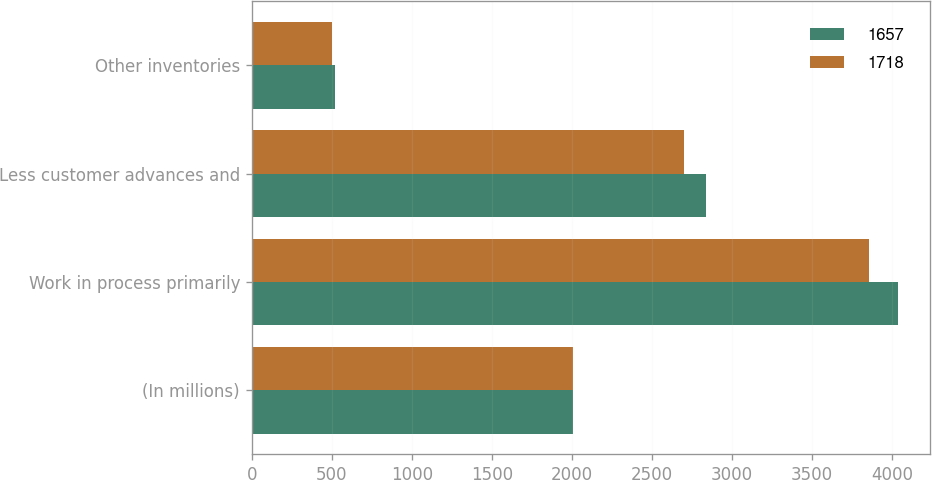Convert chart. <chart><loc_0><loc_0><loc_500><loc_500><stacked_bar_chart><ecel><fcel>(In millions)<fcel>Work in process primarily<fcel>Less customer advances and<fcel>Other inventories<nl><fcel>1657<fcel>2007<fcel>4039<fcel>2839<fcel>518<nl><fcel>1718<fcel>2006<fcel>3857<fcel>2704<fcel>504<nl></chart> 